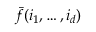<formula> <loc_0><loc_0><loc_500><loc_500>\bar { f } ( i _ { 1 } , \dots , i _ { d } )</formula> 